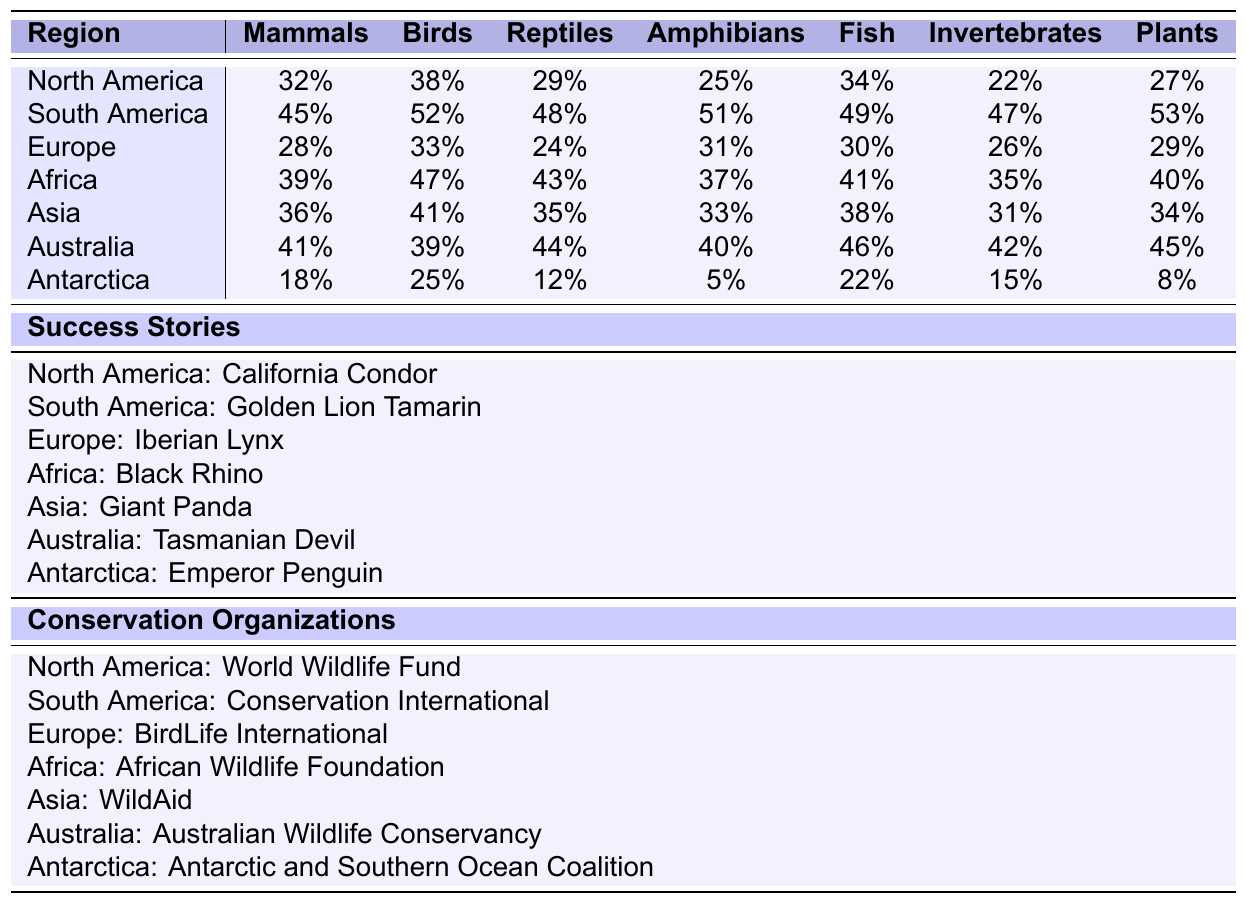What percentage of endangered mammals are saved in South America? In the table, South America has a percentage of 45% for mammals saved through conservation efforts.
Answer: 45% Which region has the highest percentage of endangered birds saved? By comparing the percentages, South America has the highest percentage of 52% for birds saved.
Answer: South America Is the percentage of saved amphibians higher in Australia or Africa? Australia has a percentage of 40% for saved amphibians, while Africa has 37%. Therefore, Australia has a higher percentage.
Answer: Australia What is the average percentage of saved reptiles across all regions? To find the average, we sum up the percentages for reptiles (29 + 48 + 24 + 43 + 35 + 44 + 12 = 235) and divide by the number of regions (7). Thus, the average is 235/7 = 33.57%, which we can round to 34%.
Answer: 34% Are there any regions with lower than 20% saved invertebrates? Checking the invertebrates column, Antarctica has 15%, which is lower than 20%. Therefore, there is a region that meets this criteria.
Answer: Yes Which region has the lowest percentage of saved plants? Looking through the plants column, Antarctica shows the lowest percentage at 8%.
Answer: Antarctica If we consider the success stories, which species corresponds to Asia? The success story for Asia listed in the table is the Giant Panda.
Answer: Giant Panda Which region shows the highest combined percentage of saved mammals, birds, and reptiles? First, we sum the percentages for each region: 
North America: 32 + 38 + 29 = 99
South America: 45 + 52 + 48 = 145
Europe: 28 + 33 + 24 = 85
Africa: 39 + 47 + 43 = 129
Asia: 36 + 41 + 35 = 112
Australia: 41 + 39 + 44 = 124
Antarctica: 18 + 25 + 12 = 55
The highest sum is for South America with 145%.
Answer: South America Does Europe have a higher percentage of saved mammals than saved amphibians? Europe has 28% for mammals and 31% for amphibians. Thus, amphibians have a higher percentage.
Answer: No Which conservation organization is associated with the success story in Europe? The table indicates that the conservation organization associated with Europe is BirdLife International.
Answer: BirdLife International 